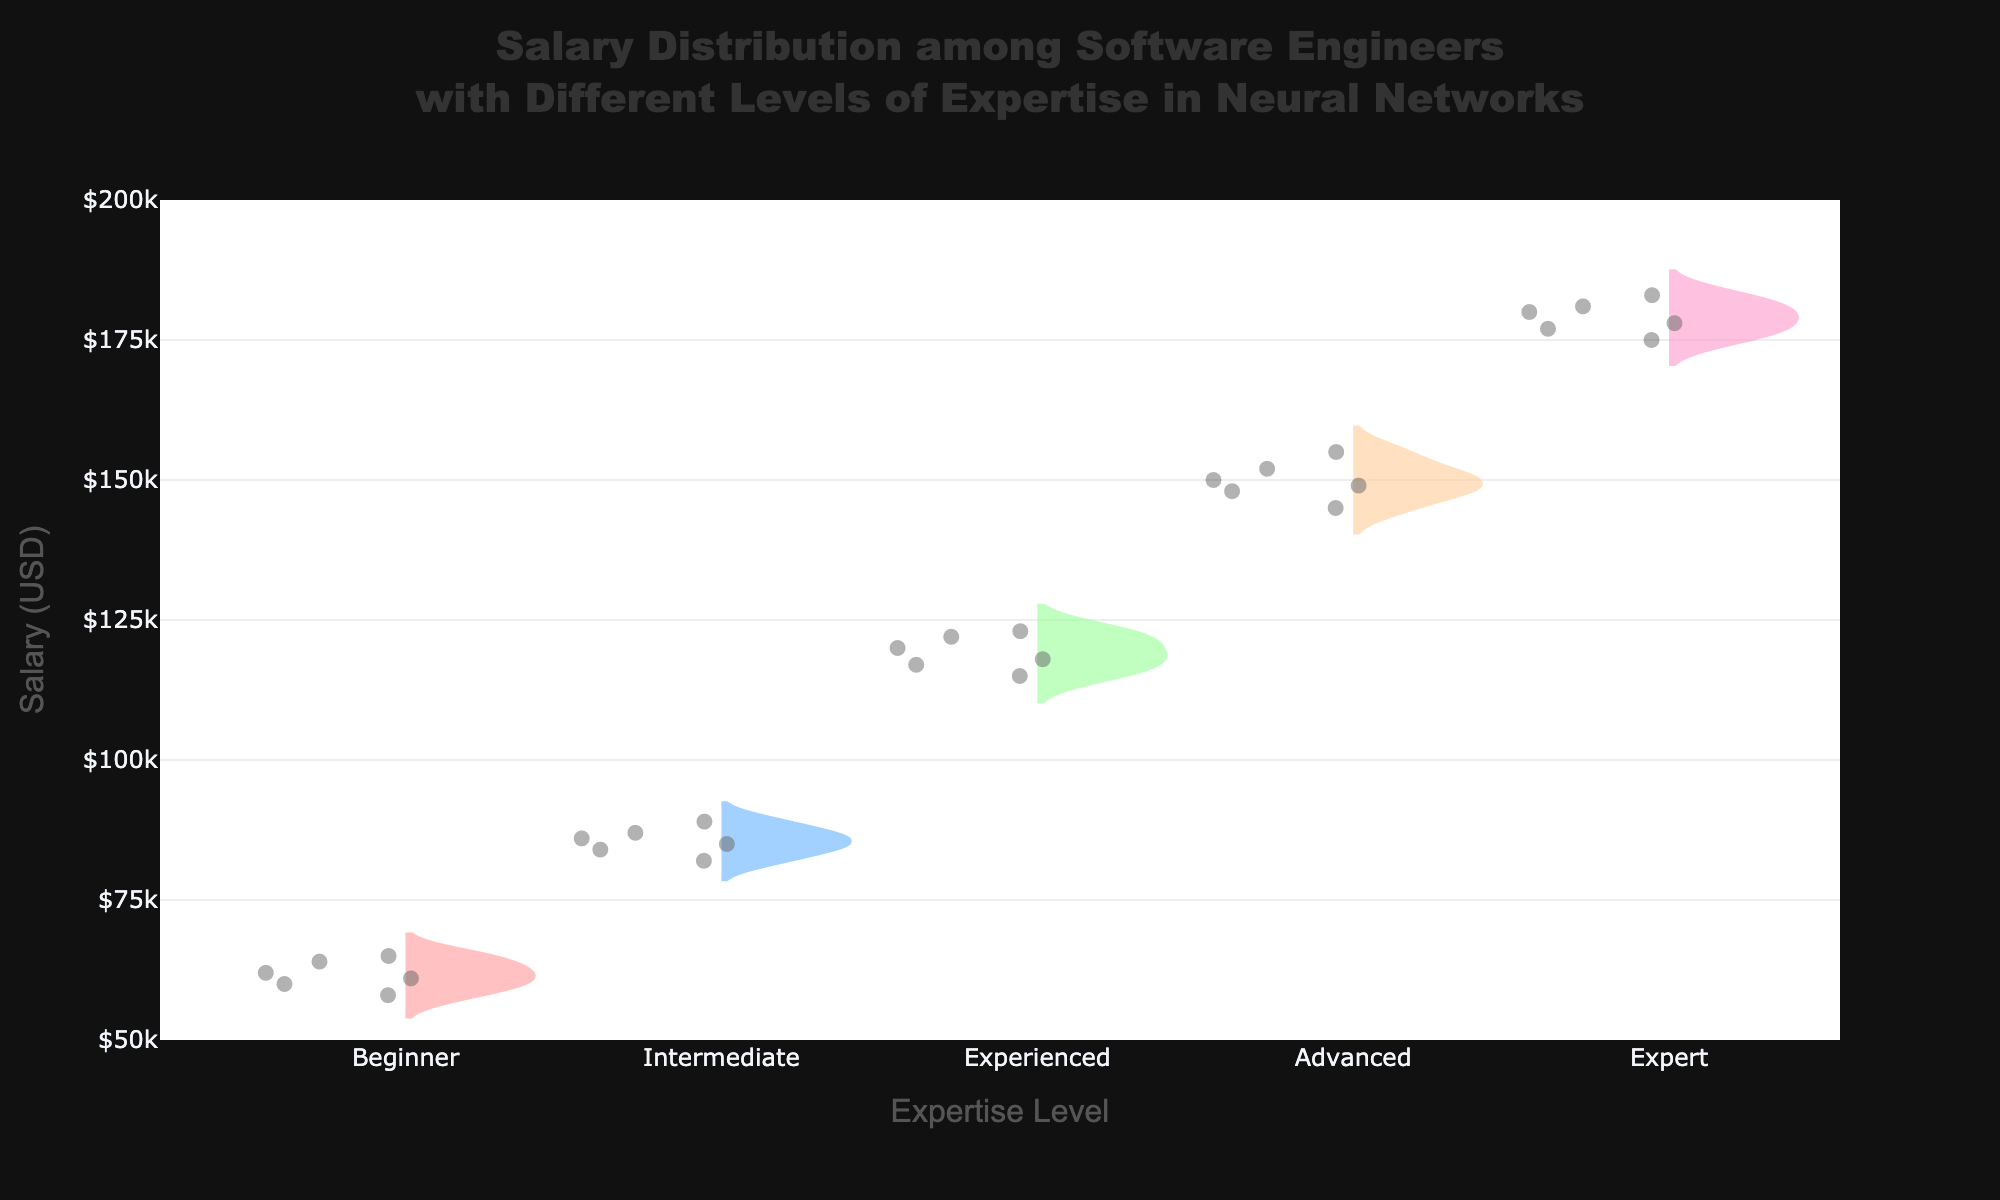what is the title of the chart? The title is usually placed at the top of the charts. In this case, it reads "Salary Distribution among Software Engineers with Different Levels of Expertise in Neural Networks."
Answer: Salary Distribution among Software Engineers with Different Levels of Expertise in Neural Networks What does the x-axis represent in this chart? The x-axis typically represents different categories or groups in a violin plot. For this chart, the x-axis represents different levels of expertise in neural networks, ranging from Beginner to Expert.
Answer: Expertise Level How many salary data points are represented for Advanced expertise level? We observe the vertical arrangement of points for Advanced level in the split violin plot, which shows all individual data points used to generate the violin. By counting these points, we see there are 6 data points.
Answer: 6 What is the color associated with the Experienced expertise level? Different colors denote different expertise levels on the chart. Observing the colors and corresponding labels, the color for Experienced expertise level is a light orange or peach shade.
Answer: light orange What is the salary range for the Beginner expertise level? The range in a violin plot is defined by the vertical span of the plot for that group. Observing the Beginner level, salaries range from $58,000 to $65,000.
Answer: $58,000 to $65,000 Which expertise level has the highest median salary? The median is typically marked within the violin plot, often indicated by a distinct line or box visible inside the distribution. For this chart, the Expert level shows the highest median salary at approximately $180,000.
Answer: Expert How does the median salary of Intermediate experts compare to that of Experienced experts? To compare medians, observe positions marked within each corresponding violin. The median of Intermediate experts is slightly below $85,000, while for Experienced it is near $120,000. Thus, Experienced experts earn more.
Answer: Experienced experts earn more Which expertise level has the widest salary distribution? The width of the violin plot indicates the distribution's frequency and spread. By comparing them, the Expert level shows the widest distribution, from around $175,000 to $183,000.
Answer: Expert What is the approximate mean salary for Advanced level? The mean is frequently marked by a distinct line or point within the violin plot. For the Advanced level, the mean salary is around $149,000 to $150,000.
Answer: $150,000 Among all expertise levels, which has the smallest number of outliers in salary? Outliers are individual points shown separately from the main bulk of the distribution in a violin plot. By comparing the segments, the Beginner level shows the fewest outliers, with points densely packed near the middle.
Answer: Beginner 